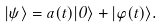Convert formula to latex. <formula><loc_0><loc_0><loc_500><loc_500>| \psi \rangle = a ( t ) | 0 \rangle + | \varphi ( t ) \rangle .</formula> 